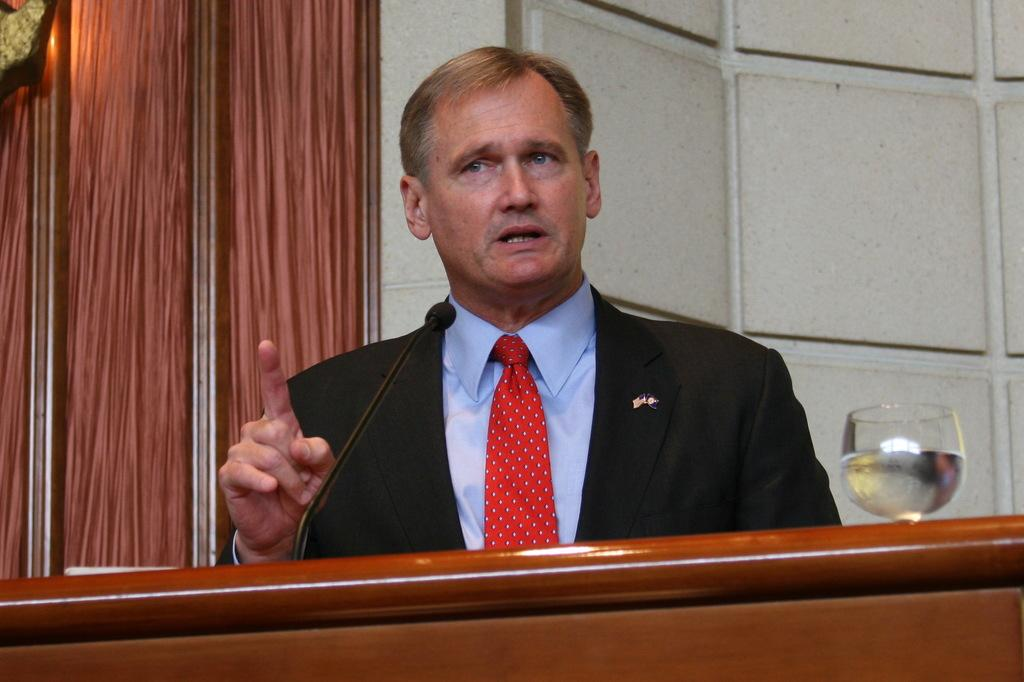Who is the main subject in the image? There is a person in the image. What is the person doing in the image? The person is talking in front of a microphone. Can you describe any other objects in the image? There is a glass with liquid in the image. What can be seen in the background of the image? There is a wall visible in the image. How many babies are crawling on the wall in the image? There are no babies present in the image, and the wall does not show any crawling babies. 